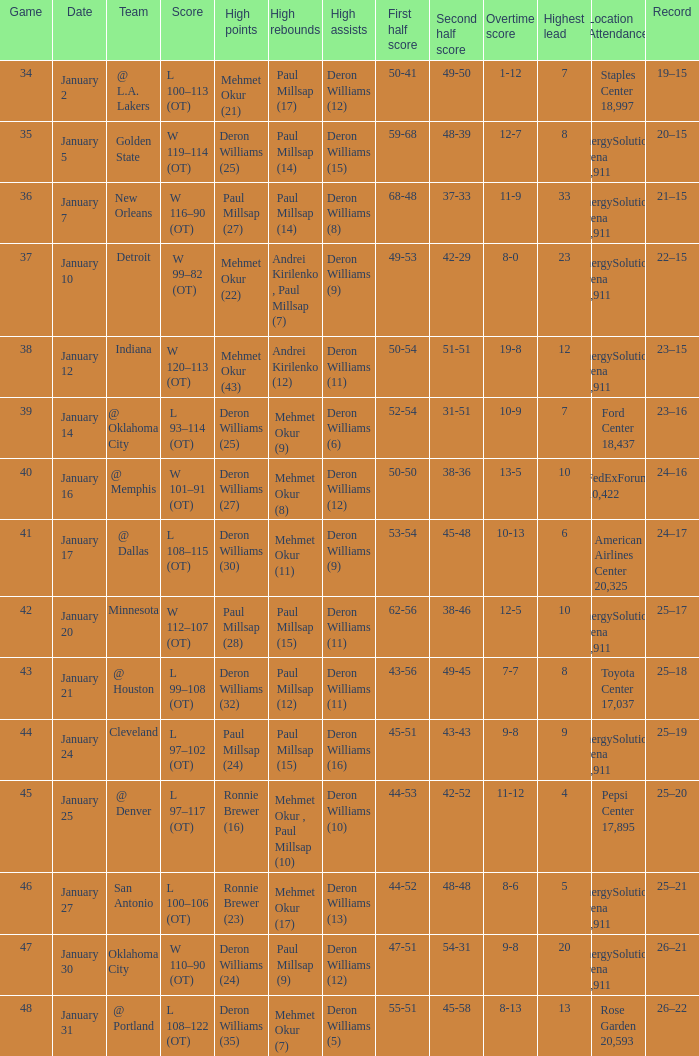Who had the high rebounds on January 24? Paul Millsap (15). 